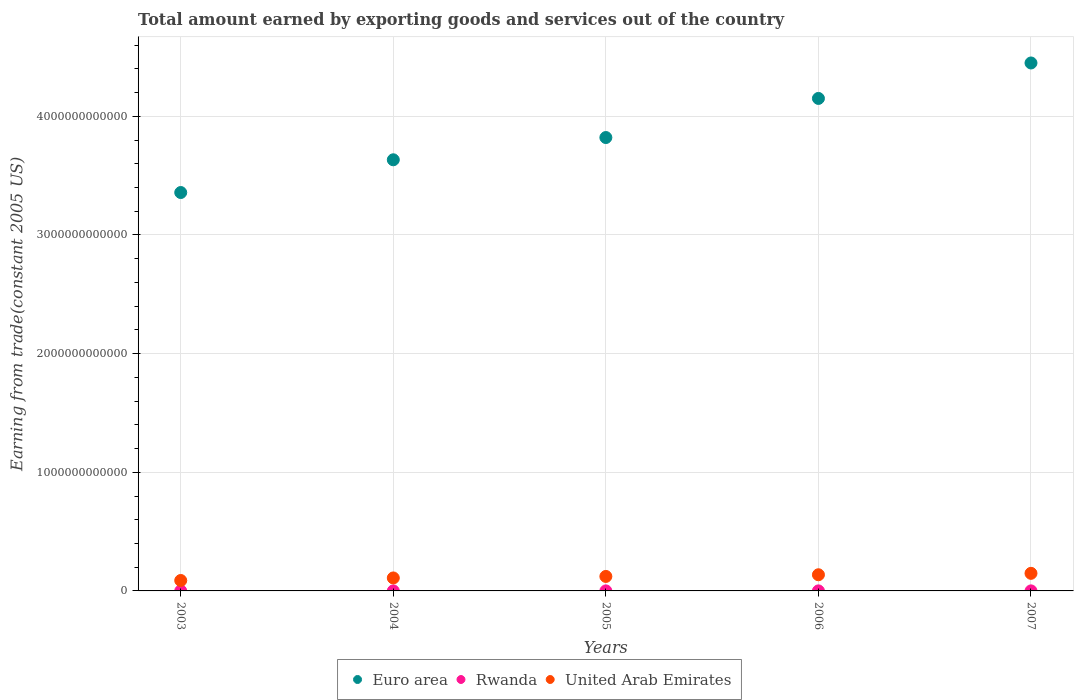Is the number of dotlines equal to the number of legend labels?
Provide a short and direct response. Yes. What is the total amount earned by exporting goods and services in Euro area in 2006?
Make the answer very short. 4.15e+12. Across all years, what is the maximum total amount earned by exporting goods and services in United Arab Emirates?
Offer a terse response. 1.48e+11. Across all years, what is the minimum total amount earned by exporting goods and services in Rwanda?
Offer a terse response. 1.57e+08. What is the total total amount earned by exporting goods and services in Rwanda in the graph?
Provide a succinct answer. 1.30e+09. What is the difference between the total amount earned by exporting goods and services in United Arab Emirates in 2003 and that in 2006?
Ensure brevity in your answer.  -4.83e+1. What is the difference between the total amount earned by exporting goods and services in Rwanda in 2004 and the total amount earned by exporting goods and services in United Arab Emirates in 2003?
Your answer should be very brief. -8.77e+1. What is the average total amount earned by exporting goods and services in Euro area per year?
Provide a succinct answer. 3.88e+12. In the year 2003, what is the difference between the total amount earned by exporting goods and services in United Arab Emirates and total amount earned by exporting goods and services in Euro area?
Provide a short and direct response. -3.27e+12. What is the ratio of the total amount earned by exporting goods and services in Euro area in 2003 to that in 2006?
Provide a succinct answer. 0.81. Is the total amount earned by exporting goods and services in Euro area in 2003 less than that in 2007?
Your answer should be compact. Yes. Is the difference between the total amount earned by exporting goods and services in United Arab Emirates in 2003 and 2005 greater than the difference between the total amount earned by exporting goods and services in Euro area in 2003 and 2005?
Provide a short and direct response. Yes. What is the difference between the highest and the second highest total amount earned by exporting goods and services in Euro area?
Your answer should be very brief. 2.99e+11. What is the difference between the highest and the lowest total amount earned by exporting goods and services in United Arab Emirates?
Offer a terse response. 6.03e+1. In how many years, is the total amount earned by exporting goods and services in Euro area greater than the average total amount earned by exporting goods and services in Euro area taken over all years?
Provide a succinct answer. 2. Is the total amount earned by exporting goods and services in Euro area strictly greater than the total amount earned by exporting goods and services in United Arab Emirates over the years?
Offer a very short reply. Yes. Is the total amount earned by exporting goods and services in United Arab Emirates strictly less than the total amount earned by exporting goods and services in Euro area over the years?
Offer a terse response. Yes. How many dotlines are there?
Make the answer very short. 3. How many years are there in the graph?
Offer a very short reply. 5. What is the difference between two consecutive major ticks on the Y-axis?
Provide a short and direct response. 1.00e+12. Where does the legend appear in the graph?
Provide a succinct answer. Bottom center. How many legend labels are there?
Offer a very short reply. 3. What is the title of the graph?
Give a very brief answer. Total amount earned by exporting goods and services out of the country. Does "Belgium" appear as one of the legend labels in the graph?
Offer a terse response. No. What is the label or title of the X-axis?
Your response must be concise. Years. What is the label or title of the Y-axis?
Provide a succinct answer. Earning from trade(constant 2005 US). What is the Earning from trade(constant 2005 US) of Euro area in 2003?
Give a very brief answer. 3.36e+12. What is the Earning from trade(constant 2005 US) in Rwanda in 2003?
Give a very brief answer. 1.57e+08. What is the Earning from trade(constant 2005 US) in United Arab Emirates in 2003?
Give a very brief answer. 8.79e+1. What is the Earning from trade(constant 2005 US) of Euro area in 2004?
Make the answer very short. 3.63e+12. What is the Earning from trade(constant 2005 US) of Rwanda in 2004?
Your answer should be compact. 2.06e+08. What is the Earning from trade(constant 2005 US) of United Arab Emirates in 2004?
Provide a succinct answer. 1.09e+11. What is the Earning from trade(constant 2005 US) of Euro area in 2005?
Offer a very short reply. 3.82e+12. What is the Earning from trade(constant 2005 US) in Rwanda in 2005?
Give a very brief answer. 2.96e+08. What is the Earning from trade(constant 2005 US) in United Arab Emirates in 2005?
Provide a short and direct response. 1.22e+11. What is the Earning from trade(constant 2005 US) of Euro area in 2006?
Offer a very short reply. 4.15e+12. What is the Earning from trade(constant 2005 US) of Rwanda in 2006?
Provide a short and direct response. 3.22e+08. What is the Earning from trade(constant 2005 US) in United Arab Emirates in 2006?
Keep it short and to the point. 1.36e+11. What is the Earning from trade(constant 2005 US) in Euro area in 2007?
Give a very brief answer. 4.45e+12. What is the Earning from trade(constant 2005 US) of Rwanda in 2007?
Provide a short and direct response. 3.17e+08. What is the Earning from trade(constant 2005 US) in United Arab Emirates in 2007?
Provide a succinct answer. 1.48e+11. Across all years, what is the maximum Earning from trade(constant 2005 US) in Euro area?
Offer a very short reply. 4.45e+12. Across all years, what is the maximum Earning from trade(constant 2005 US) of Rwanda?
Make the answer very short. 3.22e+08. Across all years, what is the maximum Earning from trade(constant 2005 US) of United Arab Emirates?
Ensure brevity in your answer.  1.48e+11. Across all years, what is the minimum Earning from trade(constant 2005 US) of Euro area?
Offer a very short reply. 3.36e+12. Across all years, what is the minimum Earning from trade(constant 2005 US) in Rwanda?
Ensure brevity in your answer.  1.57e+08. Across all years, what is the minimum Earning from trade(constant 2005 US) in United Arab Emirates?
Keep it short and to the point. 8.79e+1. What is the total Earning from trade(constant 2005 US) in Euro area in the graph?
Your answer should be very brief. 1.94e+13. What is the total Earning from trade(constant 2005 US) in Rwanda in the graph?
Offer a terse response. 1.30e+09. What is the total Earning from trade(constant 2005 US) in United Arab Emirates in the graph?
Ensure brevity in your answer.  6.04e+11. What is the difference between the Earning from trade(constant 2005 US) in Euro area in 2003 and that in 2004?
Provide a short and direct response. -2.76e+11. What is the difference between the Earning from trade(constant 2005 US) in Rwanda in 2003 and that in 2004?
Provide a short and direct response. -4.86e+07. What is the difference between the Earning from trade(constant 2005 US) of United Arab Emirates in 2003 and that in 2004?
Offer a terse response. -2.14e+1. What is the difference between the Earning from trade(constant 2005 US) in Euro area in 2003 and that in 2005?
Keep it short and to the point. -4.63e+11. What is the difference between the Earning from trade(constant 2005 US) of Rwanda in 2003 and that in 2005?
Your answer should be very brief. -1.38e+08. What is the difference between the Earning from trade(constant 2005 US) in United Arab Emirates in 2003 and that in 2005?
Offer a very short reply. -3.42e+1. What is the difference between the Earning from trade(constant 2005 US) of Euro area in 2003 and that in 2006?
Provide a short and direct response. -7.93e+11. What is the difference between the Earning from trade(constant 2005 US) in Rwanda in 2003 and that in 2006?
Provide a short and direct response. -1.65e+08. What is the difference between the Earning from trade(constant 2005 US) of United Arab Emirates in 2003 and that in 2006?
Make the answer very short. -4.83e+1. What is the difference between the Earning from trade(constant 2005 US) of Euro area in 2003 and that in 2007?
Make the answer very short. -1.09e+12. What is the difference between the Earning from trade(constant 2005 US) of Rwanda in 2003 and that in 2007?
Your answer should be very brief. -1.60e+08. What is the difference between the Earning from trade(constant 2005 US) in United Arab Emirates in 2003 and that in 2007?
Offer a very short reply. -6.03e+1. What is the difference between the Earning from trade(constant 2005 US) of Euro area in 2004 and that in 2005?
Offer a terse response. -1.88e+11. What is the difference between the Earning from trade(constant 2005 US) of Rwanda in 2004 and that in 2005?
Keep it short and to the point. -8.98e+07. What is the difference between the Earning from trade(constant 2005 US) of United Arab Emirates in 2004 and that in 2005?
Make the answer very short. -1.27e+1. What is the difference between the Earning from trade(constant 2005 US) of Euro area in 2004 and that in 2006?
Your response must be concise. -5.17e+11. What is the difference between the Earning from trade(constant 2005 US) in Rwanda in 2004 and that in 2006?
Give a very brief answer. -1.16e+08. What is the difference between the Earning from trade(constant 2005 US) of United Arab Emirates in 2004 and that in 2006?
Offer a terse response. -2.69e+1. What is the difference between the Earning from trade(constant 2005 US) in Euro area in 2004 and that in 2007?
Offer a very short reply. -8.16e+11. What is the difference between the Earning from trade(constant 2005 US) in Rwanda in 2004 and that in 2007?
Your answer should be very brief. -1.11e+08. What is the difference between the Earning from trade(constant 2005 US) in United Arab Emirates in 2004 and that in 2007?
Make the answer very short. -3.88e+1. What is the difference between the Earning from trade(constant 2005 US) of Euro area in 2005 and that in 2006?
Provide a short and direct response. -3.30e+11. What is the difference between the Earning from trade(constant 2005 US) of Rwanda in 2005 and that in 2006?
Your answer should be compact. -2.63e+07. What is the difference between the Earning from trade(constant 2005 US) in United Arab Emirates in 2005 and that in 2006?
Ensure brevity in your answer.  -1.42e+1. What is the difference between the Earning from trade(constant 2005 US) of Euro area in 2005 and that in 2007?
Make the answer very short. -6.28e+11. What is the difference between the Earning from trade(constant 2005 US) in Rwanda in 2005 and that in 2007?
Offer a very short reply. -2.14e+07. What is the difference between the Earning from trade(constant 2005 US) of United Arab Emirates in 2005 and that in 2007?
Your answer should be compact. -2.61e+1. What is the difference between the Earning from trade(constant 2005 US) of Euro area in 2006 and that in 2007?
Give a very brief answer. -2.99e+11. What is the difference between the Earning from trade(constant 2005 US) in Rwanda in 2006 and that in 2007?
Your response must be concise. 4.93e+06. What is the difference between the Earning from trade(constant 2005 US) of United Arab Emirates in 2006 and that in 2007?
Offer a terse response. -1.19e+1. What is the difference between the Earning from trade(constant 2005 US) in Euro area in 2003 and the Earning from trade(constant 2005 US) in Rwanda in 2004?
Keep it short and to the point. 3.36e+12. What is the difference between the Earning from trade(constant 2005 US) of Euro area in 2003 and the Earning from trade(constant 2005 US) of United Arab Emirates in 2004?
Your answer should be very brief. 3.25e+12. What is the difference between the Earning from trade(constant 2005 US) of Rwanda in 2003 and the Earning from trade(constant 2005 US) of United Arab Emirates in 2004?
Your answer should be compact. -1.09e+11. What is the difference between the Earning from trade(constant 2005 US) of Euro area in 2003 and the Earning from trade(constant 2005 US) of Rwanda in 2005?
Your answer should be very brief. 3.36e+12. What is the difference between the Earning from trade(constant 2005 US) in Euro area in 2003 and the Earning from trade(constant 2005 US) in United Arab Emirates in 2005?
Your answer should be very brief. 3.24e+12. What is the difference between the Earning from trade(constant 2005 US) of Rwanda in 2003 and the Earning from trade(constant 2005 US) of United Arab Emirates in 2005?
Your response must be concise. -1.22e+11. What is the difference between the Earning from trade(constant 2005 US) of Euro area in 2003 and the Earning from trade(constant 2005 US) of Rwanda in 2006?
Keep it short and to the point. 3.36e+12. What is the difference between the Earning from trade(constant 2005 US) of Euro area in 2003 and the Earning from trade(constant 2005 US) of United Arab Emirates in 2006?
Provide a short and direct response. 3.22e+12. What is the difference between the Earning from trade(constant 2005 US) of Rwanda in 2003 and the Earning from trade(constant 2005 US) of United Arab Emirates in 2006?
Give a very brief answer. -1.36e+11. What is the difference between the Earning from trade(constant 2005 US) of Euro area in 2003 and the Earning from trade(constant 2005 US) of Rwanda in 2007?
Ensure brevity in your answer.  3.36e+12. What is the difference between the Earning from trade(constant 2005 US) of Euro area in 2003 and the Earning from trade(constant 2005 US) of United Arab Emirates in 2007?
Provide a short and direct response. 3.21e+12. What is the difference between the Earning from trade(constant 2005 US) in Rwanda in 2003 and the Earning from trade(constant 2005 US) in United Arab Emirates in 2007?
Offer a terse response. -1.48e+11. What is the difference between the Earning from trade(constant 2005 US) in Euro area in 2004 and the Earning from trade(constant 2005 US) in Rwanda in 2005?
Give a very brief answer. 3.63e+12. What is the difference between the Earning from trade(constant 2005 US) of Euro area in 2004 and the Earning from trade(constant 2005 US) of United Arab Emirates in 2005?
Give a very brief answer. 3.51e+12. What is the difference between the Earning from trade(constant 2005 US) of Rwanda in 2004 and the Earning from trade(constant 2005 US) of United Arab Emirates in 2005?
Offer a very short reply. -1.22e+11. What is the difference between the Earning from trade(constant 2005 US) of Euro area in 2004 and the Earning from trade(constant 2005 US) of Rwanda in 2006?
Provide a succinct answer. 3.63e+12. What is the difference between the Earning from trade(constant 2005 US) of Euro area in 2004 and the Earning from trade(constant 2005 US) of United Arab Emirates in 2006?
Your answer should be compact. 3.50e+12. What is the difference between the Earning from trade(constant 2005 US) of Rwanda in 2004 and the Earning from trade(constant 2005 US) of United Arab Emirates in 2006?
Provide a short and direct response. -1.36e+11. What is the difference between the Earning from trade(constant 2005 US) of Euro area in 2004 and the Earning from trade(constant 2005 US) of Rwanda in 2007?
Ensure brevity in your answer.  3.63e+12. What is the difference between the Earning from trade(constant 2005 US) in Euro area in 2004 and the Earning from trade(constant 2005 US) in United Arab Emirates in 2007?
Your answer should be very brief. 3.49e+12. What is the difference between the Earning from trade(constant 2005 US) of Rwanda in 2004 and the Earning from trade(constant 2005 US) of United Arab Emirates in 2007?
Offer a terse response. -1.48e+11. What is the difference between the Earning from trade(constant 2005 US) of Euro area in 2005 and the Earning from trade(constant 2005 US) of Rwanda in 2006?
Give a very brief answer. 3.82e+12. What is the difference between the Earning from trade(constant 2005 US) in Euro area in 2005 and the Earning from trade(constant 2005 US) in United Arab Emirates in 2006?
Offer a terse response. 3.68e+12. What is the difference between the Earning from trade(constant 2005 US) of Rwanda in 2005 and the Earning from trade(constant 2005 US) of United Arab Emirates in 2006?
Offer a terse response. -1.36e+11. What is the difference between the Earning from trade(constant 2005 US) of Euro area in 2005 and the Earning from trade(constant 2005 US) of Rwanda in 2007?
Your answer should be compact. 3.82e+12. What is the difference between the Earning from trade(constant 2005 US) of Euro area in 2005 and the Earning from trade(constant 2005 US) of United Arab Emirates in 2007?
Make the answer very short. 3.67e+12. What is the difference between the Earning from trade(constant 2005 US) in Rwanda in 2005 and the Earning from trade(constant 2005 US) in United Arab Emirates in 2007?
Provide a succinct answer. -1.48e+11. What is the difference between the Earning from trade(constant 2005 US) of Euro area in 2006 and the Earning from trade(constant 2005 US) of Rwanda in 2007?
Offer a terse response. 4.15e+12. What is the difference between the Earning from trade(constant 2005 US) of Euro area in 2006 and the Earning from trade(constant 2005 US) of United Arab Emirates in 2007?
Give a very brief answer. 4.00e+12. What is the difference between the Earning from trade(constant 2005 US) in Rwanda in 2006 and the Earning from trade(constant 2005 US) in United Arab Emirates in 2007?
Ensure brevity in your answer.  -1.48e+11. What is the average Earning from trade(constant 2005 US) in Euro area per year?
Keep it short and to the point. 3.88e+12. What is the average Earning from trade(constant 2005 US) in Rwanda per year?
Your response must be concise. 2.60e+08. What is the average Earning from trade(constant 2005 US) of United Arab Emirates per year?
Ensure brevity in your answer.  1.21e+11. In the year 2003, what is the difference between the Earning from trade(constant 2005 US) of Euro area and Earning from trade(constant 2005 US) of Rwanda?
Your answer should be compact. 3.36e+12. In the year 2003, what is the difference between the Earning from trade(constant 2005 US) in Euro area and Earning from trade(constant 2005 US) in United Arab Emirates?
Offer a very short reply. 3.27e+12. In the year 2003, what is the difference between the Earning from trade(constant 2005 US) of Rwanda and Earning from trade(constant 2005 US) of United Arab Emirates?
Keep it short and to the point. -8.78e+1. In the year 2004, what is the difference between the Earning from trade(constant 2005 US) in Euro area and Earning from trade(constant 2005 US) in Rwanda?
Keep it short and to the point. 3.63e+12. In the year 2004, what is the difference between the Earning from trade(constant 2005 US) in Euro area and Earning from trade(constant 2005 US) in United Arab Emirates?
Give a very brief answer. 3.52e+12. In the year 2004, what is the difference between the Earning from trade(constant 2005 US) in Rwanda and Earning from trade(constant 2005 US) in United Arab Emirates?
Your response must be concise. -1.09e+11. In the year 2005, what is the difference between the Earning from trade(constant 2005 US) of Euro area and Earning from trade(constant 2005 US) of Rwanda?
Give a very brief answer. 3.82e+12. In the year 2005, what is the difference between the Earning from trade(constant 2005 US) of Euro area and Earning from trade(constant 2005 US) of United Arab Emirates?
Keep it short and to the point. 3.70e+12. In the year 2005, what is the difference between the Earning from trade(constant 2005 US) of Rwanda and Earning from trade(constant 2005 US) of United Arab Emirates?
Provide a short and direct response. -1.22e+11. In the year 2006, what is the difference between the Earning from trade(constant 2005 US) in Euro area and Earning from trade(constant 2005 US) in Rwanda?
Keep it short and to the point. 4.15e+12. In the year 2006, what is the difference between the Earning from trade(constant 2005 US) of Euro area and Earning from trade(constant 2005 US) of United Arab Emirates?
Your answer should be compact. 4.01e+12. In the year 2006, what is the difference between the Earning from trade(constant 2005 US) in Rwanda and Earning from trade(constant 2005 US) in United Arab Emirates?
Ensure brevity in your answer.  -1.36e+11. In the year 2007, what is the difference between the Earning from trade(constant 2005 US) in Euro area and Earning from trade(constant 2005 US) in Rwanda?
Your response must be concise. 4.45e+12. In the year 2007, what is the difference between the Earning from trade(constant 2005 US) of Euro area and Earning from trade(constant 2005 US) of United Arab Emirates?
Give a very brief answer. 4.30e+12. In the year 2007, what is the difference between the Earning from trade(constant 2005 US) of Rwanda and Earning from trade(constant 2005 US) of United Arab Emirates?
Ensure brevity in your answer.  -1.48e+11. What is the ratio of the Earning from trade(constant 2005 US) of Euro area in 2003 to that in 2004?
Offer a very short reply. 0.92. What is the ratio of the Earning from trade(constant 2005 US) in Rwanda in 2003 to that in 2004?
Your response must be concise. 0.76. What is the ratio of the Earning from trade(constant 2005 US) in United Arab Emirates in 2003 to that in 2004?
Keep it short and to the point. 0.8. What is the ratio of the Earning from trade(constant 2005 US) in Euro area in 2003 to that in 2005?
Your response must be concise. 0.88. What is the ratio of the Earning from trade(constant 2005 US) in Rwanda in 2003 to that in 2005?
Offer a terse response. 0.53. What is the ratio of the Earning from trade(constant 2005 US) of United Arab Emirates in 2003 to that in 2005?
Give a very brief answer. 0.72. What is the ratio of the Earning from trade(constant 2005 US) in Euro area in 2003 to that in 2006?
Provide a short and direct response. 0.81. What is the ratio of the Earning from trade(constant 2005 US) in Rwanda in 2003 to that in 2006?
Your response must be concise. 0.49. What is the ratio of the Earning from trade(constant 2005 US) of United Arab Emirates in 2003 to that in 2006?
Offer a terse response. 0.65. What is the ratio of the Earning from trade(constant 2005 US) of Euro area in 2003 to that in 2007?
Give a very brief answer. 0.75. What is the ratio of the Earning from trade(constant 2005 US) in Rwanda in 2003 to that in 2007?
Make the answer very short. 0.5. What is the ratio of the Earning from trade(constant 2005 US) of United Arab Emirates in 2003 to that in 2007?
Provide a succinct answer. 0.59. What is the ratio of the Earning from trade(constant 2005 US) of Euro area in 2004 to that in 2005?
Your answer should be very brief. 0.95. What is the ratio of the Earning from trade(constant 2005 US) in Rwanda in 2004 to that in 2005?
Make the answer very short. 0.7. What is the ratio of the Earning from trade(constant 2005 US) in United Arab Emirates in 2004 to that in 2005?
Your answer should be very brief. 0.9. What is the ratio of the Earning from trade(constant 2005 US) of Euro area in 2004 to that in 2006?
Give a very brief answer. 0.88. What is the ratio of the Earning from trade(constant 2005 US) in Rwanda in 2004 to that in 2006?
Offer a very short reply. 0.64. What is the ratio of the Earning from trade(constant 2005 US) in United Arab Emirates in 2004 to that in 2006?
Your response must be concise. 0.8. What is the ratio of the Earning from trade(constant 2005 US) in Euro area in 2004 to that in 2007?
Make the answer very short. 0.82. What is the ratio of the Earning from trade(constant 2005 US) of Rwanda in 2004 to that in 2007?
Give a very brief answer. 0.65. What is the ratio of the Earning from trade(constant 2005 US) in United Arab Emirates in 2004 to that in 2007?
Provide a short and direct response. 0.74. What is the ratio of the Earning from trade(constant 2005 US) in Euro area in 2005 to that in 2006?
Your response must be concise. 0.92. What is the ratio of the Earning from trade(constant 2005 US) in Rwanda in 2005 to that in 2006?
Give a very brief answer. 0.92. What is the ratio of the Earning from trade(constant 2005 US) of United Arab Emirates in 2005 to that in 2006?
Make the answer very short. 0.9. What is the ratio of the Earning from trade(constant 2005 US) in Euro area in 2005 to that in 2007?
Provide a succinct answer. 0.86. What is the ratio of the Earning from trade(constant 2005 US) of Rwanda in 2005 to that in 2007?
Offer a terse response. 0.93. What is the ratio of the Earning from trade(constant 2005 US) in United Arab Emirates in 2005 to that in 2007?
Make the answer very short. 0.82. What is the ratio of the Earning from trade(constant 2005 US) of Euro area in 2006 to that in 2007?
Make the answer very short. 0.93. What is the ratio of the Earning from trade(constant 2005 US) of Rwanda in 2006 to that in 2007?
Keep it short and to the point. 1.02. What is the ratio of the Earning from trade(constant 2005 US) of United Arab Emirates in 2006 to that in 2007?
Your answer should be very brief. 0.92. What is the difference between the highest and the second highest Earning from trade(constant 2005 US) in Euro area?
Ensure brevity in your answer.  2.99e+11. What is the difference between the highest and the second highest Earning from trade(constant 2005 US) in Rwanda?
Your response must be concise. 4.93e+06. What is the difference between the highest and the second highest Earning from trade(constant 2005 US) of United Arab Emirates?
Keep it short and to the point. 1.19e+1. What is the difference between the highest and the lowest Earning from trade(constant 2005 US) of Euro area?
Make the answer very short. 1.09e+12. What is the difference between the highest and the lowest Earning from trade(constant 2005 US) of Rwanda?
Ensure brevity in your answer.  1.65e+08. What is the difference between the highest and the lowest Earning from trade(constant 2005 US) in United Arab Emirates?
Provide a short and direct response. 6.03e+1. 